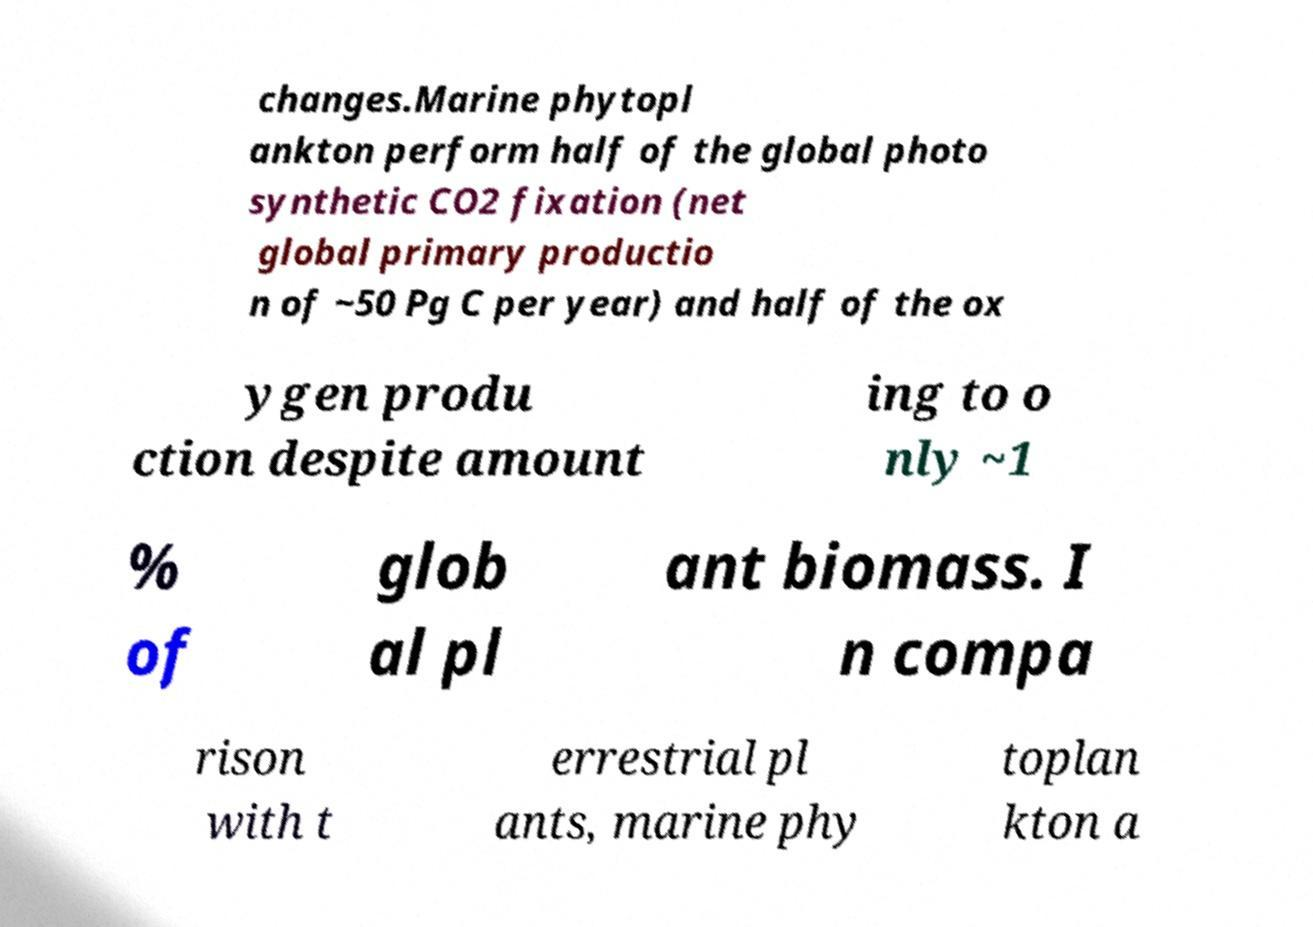Can you accurately transcribe the text from the provided image for me? changes.Marine phytopl ankton perform half of the global photo synthetic CO2 fixation (net global primary productio n of ~50 Pg C per year) and half of the ox ygen produ ction despite amount ing to o nly ~1 % of glob al pl ant biomass. I n compa rison with t errestrial pl ants, marine phy toplan kton a 